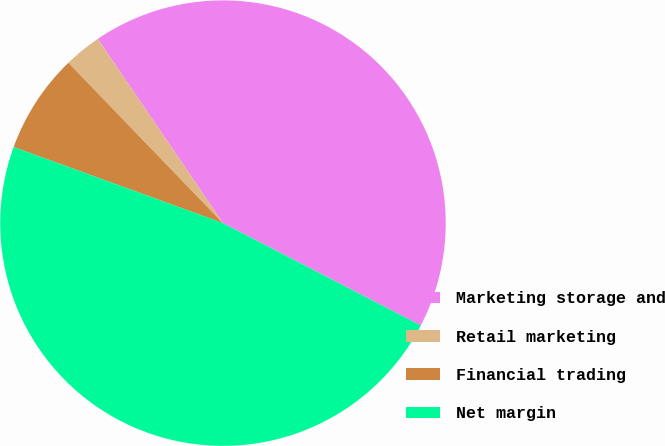<chart> <loc_0><loc_0><loc_500><loc_500><pie_chart><fcel>Marketing storage and<fcel>Retail marketing<fcel>Financial trading<fcel>Net margin<nl><fcel>42.1%<fcel>2.71%<fcel>7.24%<fcel>47.95%<nl></chart> 